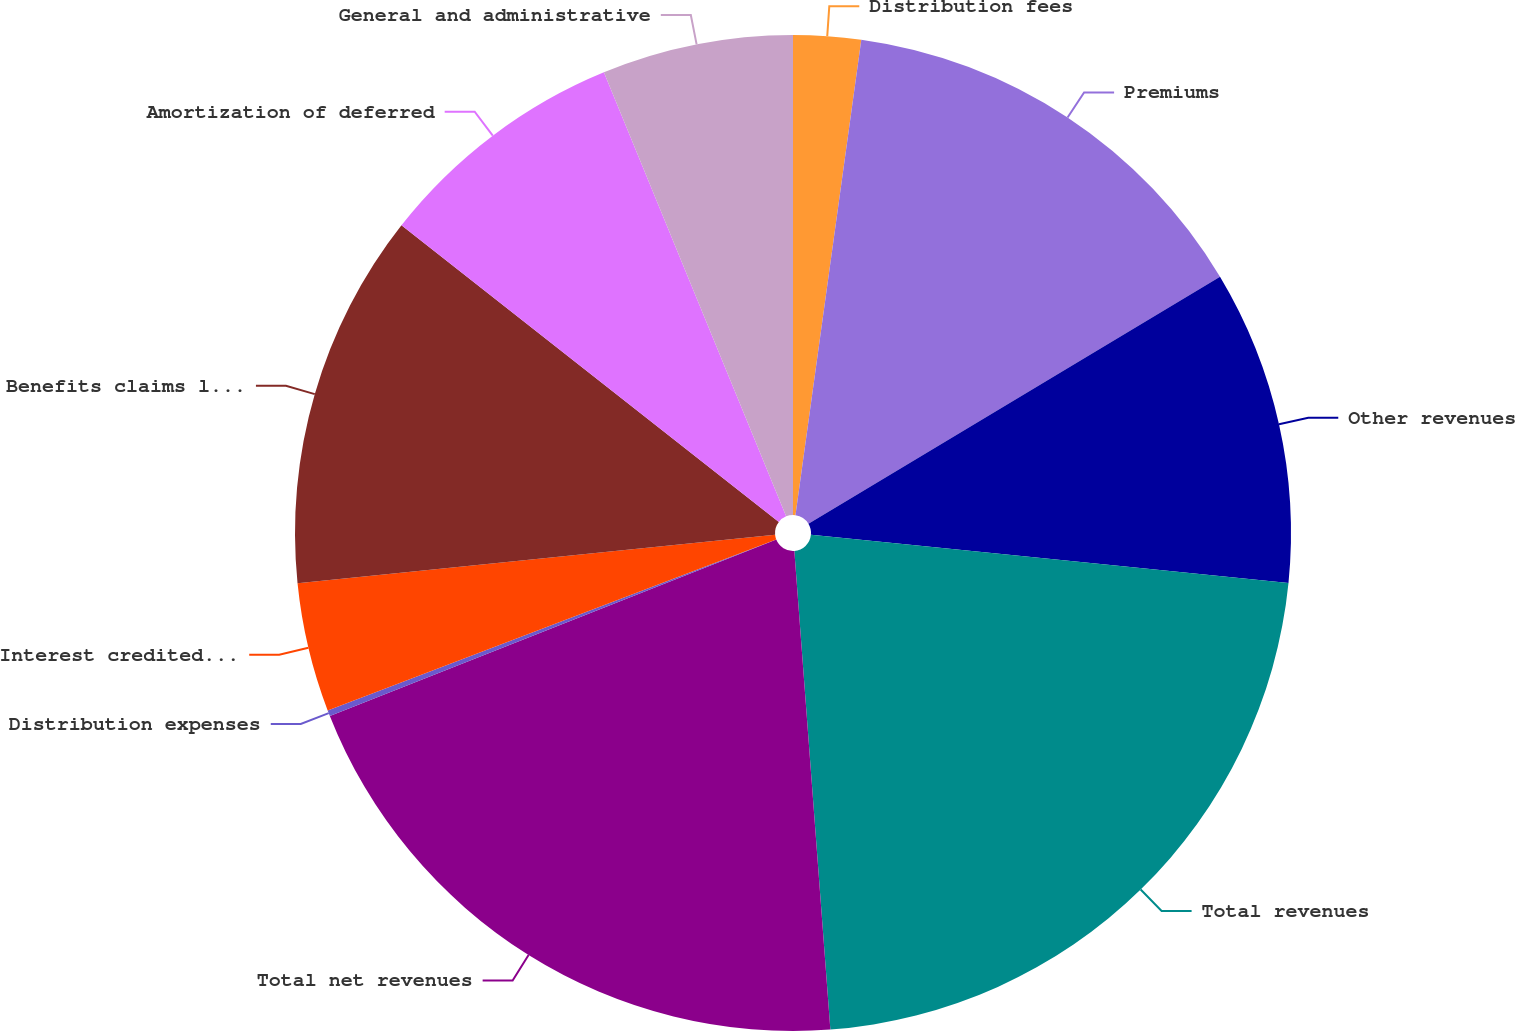<chart> <loc_0><loc_0><loc_500><loc_500><pie_chart><fcel>Distribution fees<fcel>Premiums<fcel>Other revenues<fcel>Total revenues<fcel>Total net revenues<fcel>Distribution expenses<fcel>Interest credited to fixed<fcel>Benefits claims losses and<fcel>Amortization of deferred<fcel>General and administrative<nl><fcel>2.19%<fcel>14.21%<fcel>10.2%<fcel>22.21%<fcel>20.21%<fcel>0.19%<fcel>4.19%<fcel>12.21%<fcel>8.2%<fcel>6.2%<nl></chart> 